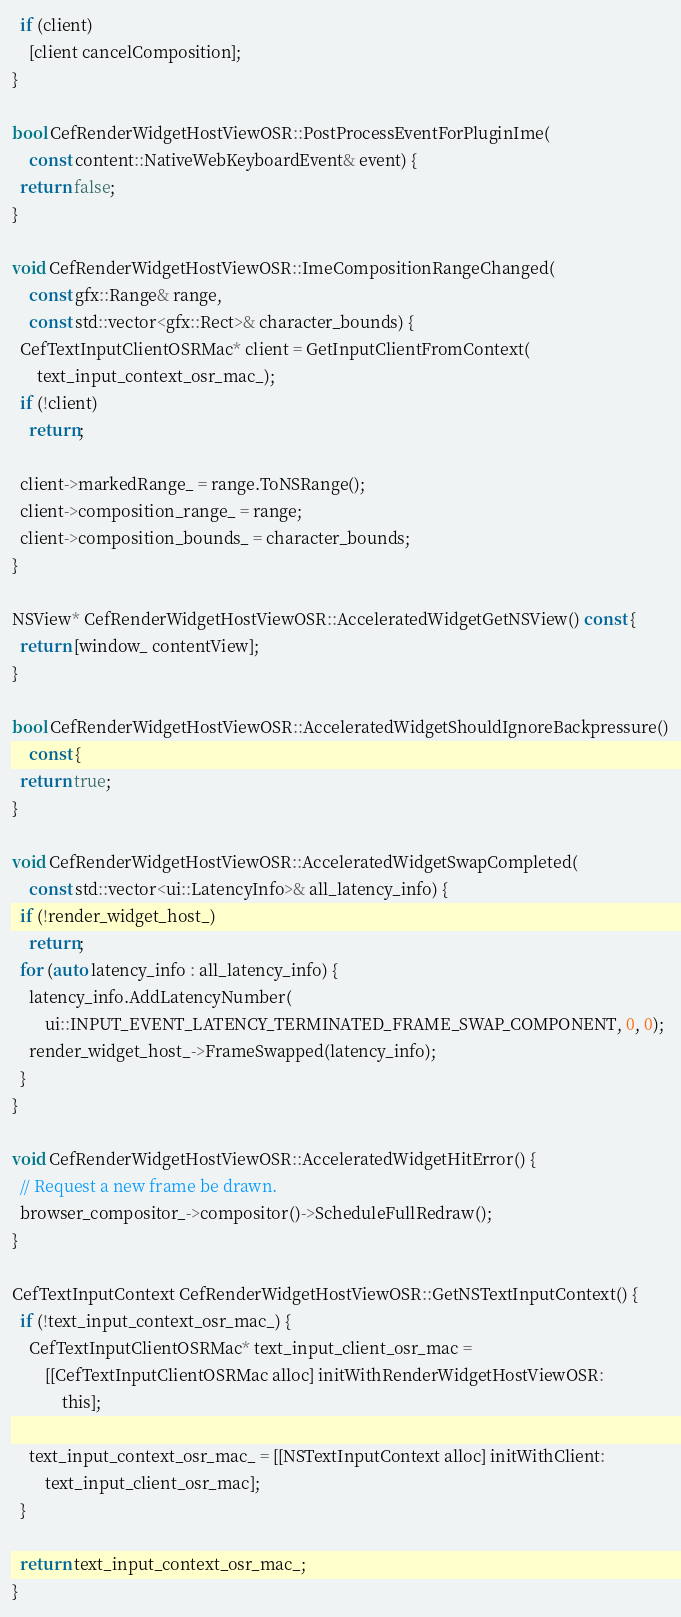<code> <loc_0><loc_0><loc_500><loc_500><_ObjectiveC_>  if (client)
    [client cancelComposition];
}

bool CefRenderWidgetHostViewOSR::PostProcessEventForPluginIme(
    const content::NativeWebKeyboardEvent& event) {
  return false;
}

void CefRenderWidgetHostViewOSR::ImeCompositionRangeChanged(
    const gfx::Range& range,
    const std::vector<gfx::Rect>& character_bounds) {
  CefTextInputClientOSRMac* client = GetInputClientFromContext(
      text_input_context_osr_mac_);
  if (!client)
    return;

  client->markedRange_ = range.ToNSRange();
  client->composition_range_ = range;
  client->composition_bounds_ = character_bounds;
}

NSView* CefRenderWidgetHostViewOSR::AcceleratedWidgetGetNSView() const {
  return [window_ contentView];
}

bool CefRenderWidgetHostViewOSR::AcceleratedWidgetShouldIgnoreBackpressure()
    const {
  return true;
}

void CefRenderWidgetHostViewOSR::AcceleratedWidgetSwapCompleted(
    const std::vector<ui::LatencyInfo>& all_latency_info) {
  if (!render_widget_host_)
    return;
  for (auto latency_info : all_latency_info) {
    latency_info.AddLatencyNumber(
        ui::INPUT_EVENT_LATENCY_TERMINATED_FRAME_SWAP_COMPONENT, 0, 0);
    render_widget_host_->FrameSwapped(latency_info);
  }
}

void CefRenderWidgetHostViewOSR::AcceleratedWidgetHitError() {
  // Request a new frame be drawn.
  browser_compositor_->compositor()->ScheduleFullRedraw();
}

CefTextInputContext CefRenderWidgetHostViewOSR::GetNSTextInputContext() {
  if (!text_input_context_osr_mac_) {
    CefTextInputClientOSRMac* text_input_client_osr_mac =
        [[CefTextInputClientOSRMac alloc] initWithRenderWidgetHostViewOSR:
            this];

    text_input_context_osr_mac_ = [[NSTextInputContext alloc] initWithClient:
        text_input_client_osr_mac];
  }

  return text_input_context_osr_mac_;
}
</code> 